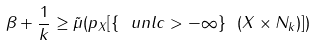<formula> <loc_0><loc_0><loc_500><loc_500>\beta + \frac { 1 } { k } \geq \tilde { \mu } ( p _ { X } [ \{ \ u n l c > - \infty \} \ ( X \times N _ { k } ) ] )</formula> 